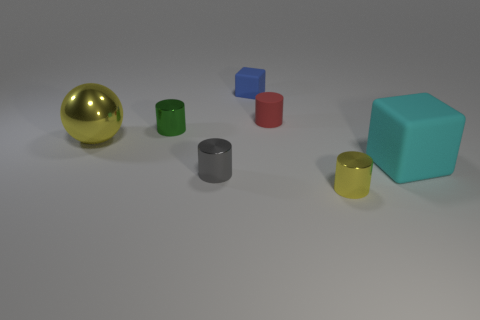What is the large cyan object made of?
Your answer should be compact. Rubber. The rubber cube that is the same size as the yellow sphere is what color?
Your answer should be very brief. Cyan. There is a big yellow sphere in front of the small red rubber thing; are there any big yellow metallic things behind it?
Your answer should be very brief. No. What number of cylinders are yellow shiny objects or gray things?
Ensure brevity in your answer.  2. What is the size of the yellow object that is behind the rubber block to the right of the matte cube behind the big cyan rubber thing?
Provide a succinct answer. Large. Are there any small metallic things left of the yellow metallic ball?
Your answer should be very brief. No. What is the shape of the tiny metal object that is the same color as the ball?
Give a very brief answer. Cylinder. What number of objects are small metallic cylinders right of the green metal cylinder or green balls?
Your answer should be very brief. 2. There is a yellow sphere that is the same material as the green cylinder; what size is it?
Provide a short and direct response. Large. There is a blue object; is its size the same as the green metal cylinder to the left of the small gray metal cylinder?
Provide a short and direct response. Yes. 